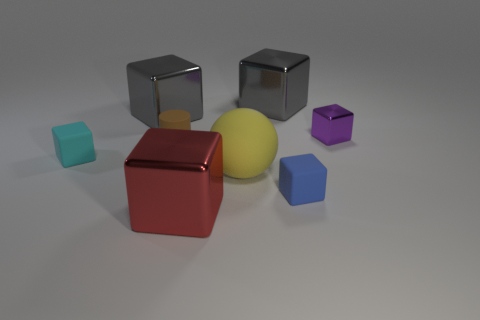What number of rubber things are large red spheres or red things?
Provide a succinct answer. 0. The large red object that is the same material as the tiny purple thing is what shape?
Ensure brevity in your answer.  Cube. What number of big gray objects are left of the ball and right of the brown cylinder?
Provide a succinct answer. 0. Is there anything else that has the same shape as the large yellow rubber thing?
Ensure brevity in your answer.  No. There is a brown matte object right of the tiny cyan block; what size is it?
Your response must be concise. Small. How many other things are there of the same color as the big matte sphere?
Your answer should be compact. 0. What material is the gray object in front of the large block to the right of the large matte thing made of?
Your response must be concise. Metal. There is a tiny cylinder left of the yellow matte thing; is its color the same as the big matte ball?
Keep it short and to the point. No. Is there any other thing that has the same material as the small purple thing?
Your response must be concise. Yes. How many other metal objects have the same shape as the cyan object?
Provide a short and direct response. 4. 